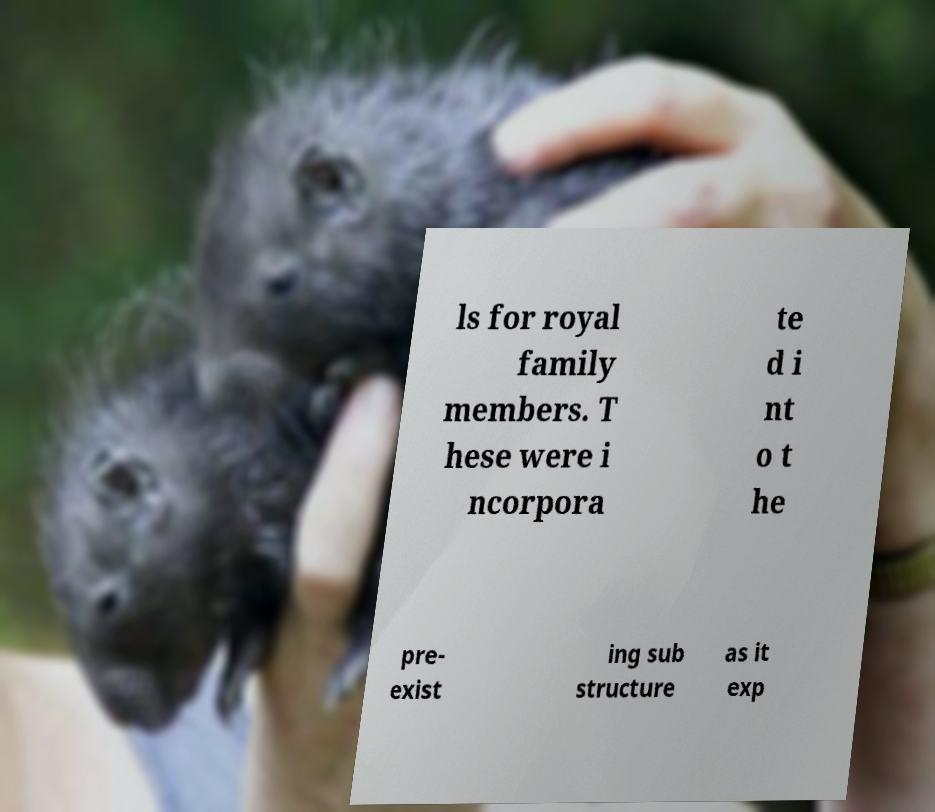Can you read and provide the text displayed in the image?This photo seems to have some interesting text. Can you extract and type it out for me? ls for royal family members. T hese were i ncorpora te d i nt o t he pre- exist ing sub structure as it exp 